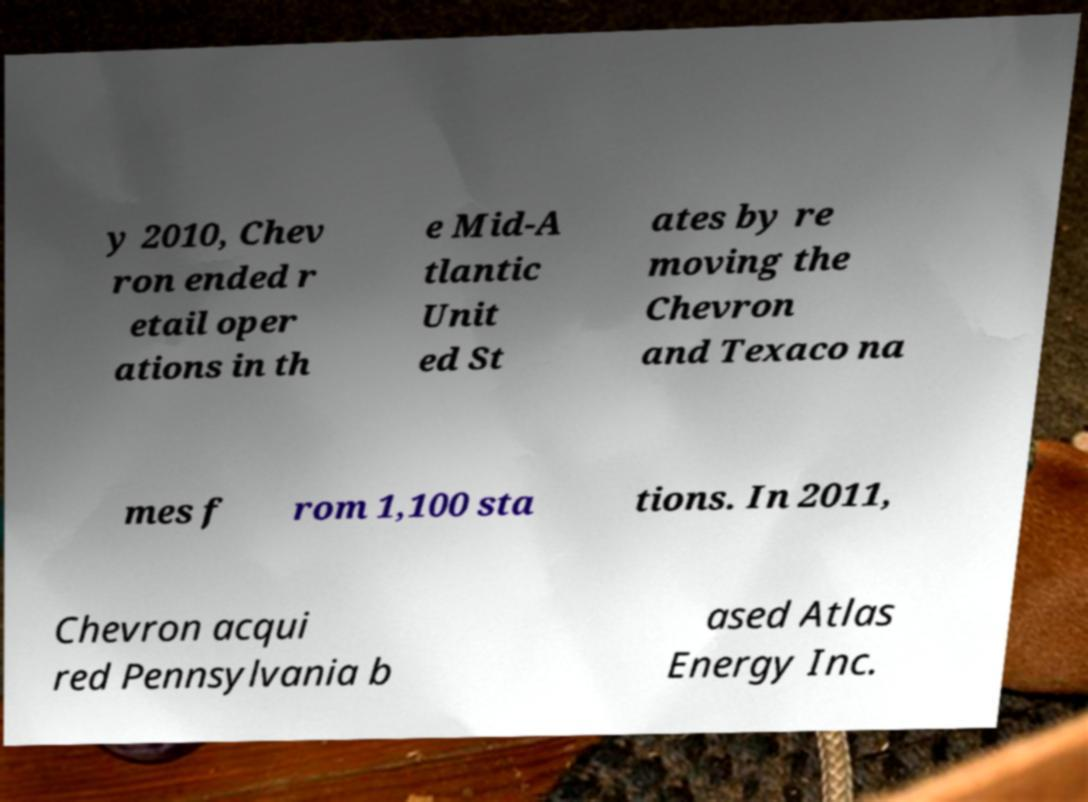There's text embedded in this image that I need extracted. Can you transcribe it verbatim? y 2010, Chev ron ended r etail oper ations in th e Mid-A tlantic Unit ed St ates by re moving the Chevron and Texaco na mes f rom 1,100 sta tions. In 2011, Chevron acqui red Pennsylvania b ased Atlas Energy Inc. 